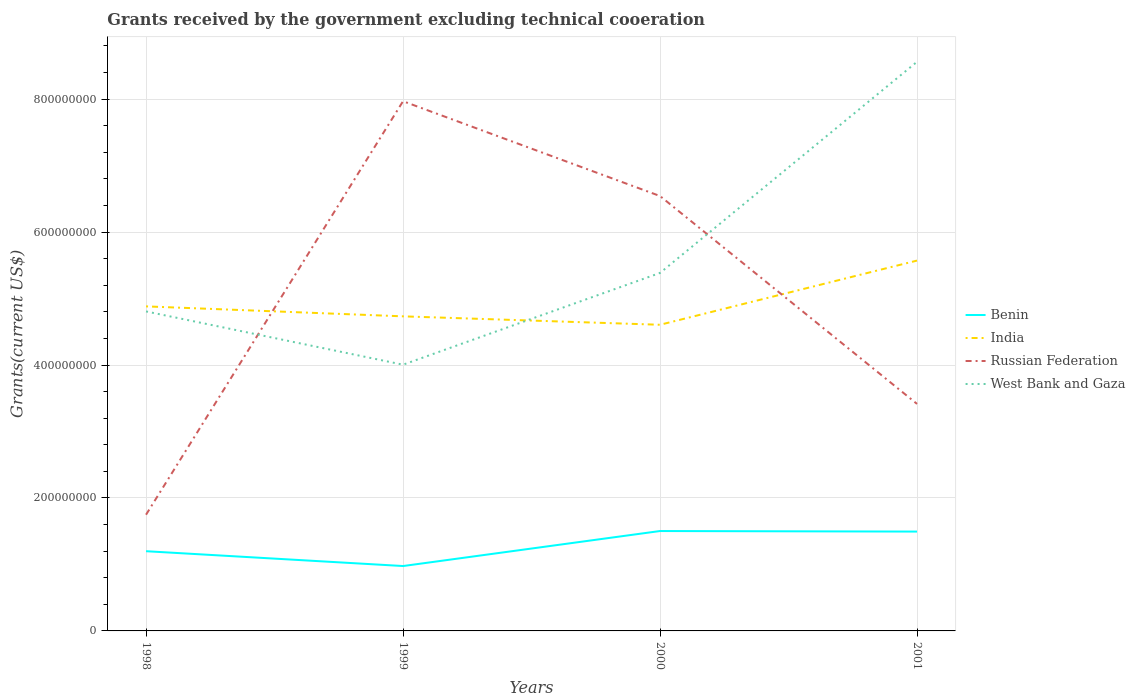How many different coloured lines are there?
Provide a short and direct response. 4. Across all years, what is the maximum total grants received by the government in Benin?
Keep it short and to the point. 9.76e+07. In which year was the total grants received by the government in Russian Federation maximum?
Keep it short and to the point. 1998. What is the total total grants received by the government in India in the graph?
Your answer should be compact. -9.66e+07. What is the difference between the highest and the second highest total grants received by the government in Benin?
Your answer should be compact. 5.27e+07. What is the difference between the highest and the lowest total grants received by the government in India?
Offer a very short reply. 1. How many lines are there?
Make the answer very short. 4. How many years are there in the graph?
Keep it short and to the point. 4. Are the values on the major ticks of Y-axis written in scientific E-notation?
Your response must be concise. No. Does the graph contain any zero values?
Ensure brevity in your answer.  No. How are the legend labels stacked?
Your answer should be compact. Vertical. What is the title of the graph?
Your answer should be very brief. Grants received by the government excluding technical cooeration. What is the label or title of the X-axis?
Ensure brevity in your answer.  Years. What is the label or title of the Y-axis?
Ensure brevity in your answer.  Grants(current US$). What is the Grants(current US$) in Benin in 1998?
Keep it short and to the point. 1.20e+08. What is the Grants(current US$) of India in 1998?
Offer a terse response. 4.88e+08. What is the Grants(current US$) in Russian Federation in 1998?
Give a very brief answer. 1.75e+08. What is the Grants(current US$) of West Bank and Gaza in 1998?
Offer a very short reply. 4.81e+08. What is the Grants(current US$) in Benin in 1999?
Offer a very short reply. 9.76e+07. What is the Grants(current US$) in India in 1999?
Your answer should be very brief. 4.73e+08. What is the Grants(current US$) of Russian Federation in 1999?
Make the answer very short. 7.97e+08. What is the Grants(current US$) in West Bank and Gaza in 1999?
Provide a short and direct response. 4.01e+08. What is the Grants(current US$) of Benin in 2000?
Ensure brevity in your answer.  1.50e+08. What is the Grants(current US$) in India in 2000?
Keep it short and to the point. 4.61e+08. What is the Grants(current US$) in Russian Federation in 2000?
Ensure brevity in your answer.  6.54e+08. What is the Grants(current US$) of West Bank and Gaza in 2000?
Provide a succinct answer. 5.39e+08. What is the Grants(current US$) of Benin in 2001?
Your response must be concise. 1.49e+08. What is the Grants(current US$) of India in 2001?
Provide a succinct answer. 5.57e+08. What is the Grants(current US$) in Russian Federation in 2001?
Ensure brevity in your answer.  3.42e+08. What is the Grants(current US$) of West Bank and Gaza in 2001?
Provide a succinct answer. 8.56e+08. Across all years, what is the maximum Grants(current US$) in Benin?
Offer a very short reply. 1.50e+08. Across all years, what is the maximum Grants(current US$) of India?
Provide a short and direct response. 5.57e+08. Across all years, what is the maximum Grants(current US$) of Russian Federation?
Your answer should be compact. 7.97e+08. Across all years, what is the maximum Grants(current US$) of West Bank and Gaza?
Your answer should be compact. 8.56e+08. Across all years, what is the minimum Grants(current US$) of Benin?
Provide a short and direct response. 9.76e+07. Across all years, what is the minimum Grants(current US$) of India?
Your answer should be compact. 4.61e+08. Across all years, what is the minimum Grants(current US$) of Russian Federation?
Offer a very short reply. 1.75e+08. Across all years, what is the minimum Grants(current US$) in West Bank and Gaza?
Make the answer very short. 4.01e+08. What is the total Grants(current US$) of Benin in the graph?
Make the answer very short. 5.17e+08. What is the total Grants(current US$) of India in the graph?
Offer a very short reply. 1.98e+09. What is the total Grants(current US$) of Russian Federation in the graph?
Provide a succinct answer. 1.97e+09. What is the total Grants(current US$) of West Bank and Gaza in the graph?
Provide a short and direct response. 2.28e+09. What is the difference between the Grants(current US$) in Benin in 1998 and that in 1999?
Your answer should be very brief. 2.23e+07. What is the difference between the Grants(current US$) in India in 1998 and that in 1999?
Offer a terse response. 1.50e+07. What is the difference between the Grants(current US$) in Russian Federation in 1998 and that in 1999?
Your response must be concise. -6.22e+08. What is the difference between the Grants(current US$) of West Bank and Gaza in 1998 and that in 1999?
Your answer should be very brief. 8.02e+07. What is the difference between the Grants(current US$) in Benin in 1998 and that in 2000?
Provide a succinct answer. -3.04e+07. What is the difference between the Grants(current US$) in India in 1998 and that in 2000?
Give a very brief answer. 2.77e+07. What is the difference between the Grants(current US$) of Russian Federation in 1998 and that in 2000?
Keep it short and to the point. -4.79e+08. What is the difference between the Grants(current US$) of West Bank and Gaza in 1998 and that in 2000?
Offer a very short reply. -5.79e+07. What is the difference between the Grants(current US$) of Benin in 1998 and that in 2001?
Make the answer very short. -2.95e+07. What is the difference between the Grants(current US$) of India in 1998 and that in 2001?
Keep it short and to the point. -6.89e+07. What is the difference between the Grants(current US$) in Russian Federation in 1998 and that in 2001?
Ensure brevity in your answer.  -1.67e+08. What is the difference between the Grants(current US$) of West Bank and Gaza in 1998 and that in 2001?
Ensure brevity in your answer.  -3.76e+08. What is the difference between the Grants(current US$) in Benin in 1999 and that in 2000?
Provide a succinct answer. -5.27e+07. What is the difference between the Grants(current US$) in India in 1999 and that in 2000?
Provide a short and direct response. 1.27e+07. What is the difference between the Grants(current US$) in Russian Federation in 1999 and that in 2000?
Your response must be concise. 1.43e+08. What is the difference between the Grants(current US$) in West Bank and Gaza in 1999 and that in 2000?
Keep it short and to the point. -1.38e+08. What is the difference between the Grants(current US$) of Benin in 1999 and that in 2001?
Make the answer very short. -5.18e+07. What is the difference between the Grants(current US$) of India in 1999 and that in 2001?
Give a very brief answer. -8.39e+07. What is the difference between the Grants(current US$) of Russian Federation in 1999 and that in 2001?
Give a very brief answer. 4.55e+08. What is the difference between the Grants(current US$) in West Bank and Gaza in 1999 and that in 2001?
Your answer should be compact. -4.56e+08. What is the difference between the Grants(current US$) of Benin in 2000 and that in 2001?
Keep it short and to the point. 8.30e+05. What is the difference between the Grants(current US$) in India in 2000 and that in 2001?
Your answer should be very brief. -9.66e+07. What is the difference between the Grants(current US$) in Russian Federation in 2000 and that in 2001?
Ensure brevity in your answer.  3.13e+08. What is the difference between the Grants(current US$) in West Bank and Gaza in 2000 and that in 2001?
Offer a very short reply. -3.18e+08. What is the difference between the Grants(current US$) in Benin in 1998 and the Grants(current US$) in India in 1999?
Keep it short and to the point. -3.53e+08. What is the difference between the Grants(current US$) in Benin in 1998 and the Grants(current US$) in Russian Federation in 1999?
Provide a short and direct response. -6.77e+08. What is the difference between the Grants(current US$) of Benin in 1998 and the Grants(current US$) of West Bank and Gaza in 1999?
Provide a succinct answer. -2.81e+08. What is the difference between the Grants(current US$) of India in 1998 and the Grants(current US$) of Russian Federation in 1999?
Offer a very short reply. -3.09e+08. What is the difference between the Grants(current US$) in India in 1998 and the Grants(current US$) in West Bank and Gaza in 1999?
Ensure brevity in your answer.  8.77e+07. What is the difference between the Grants(current US$) of Russian Federation in 1998 and the Grants(current US$) of West Bank and Gaza in 1999?
Offer a very short reply. -2.26e+08. What is the difference between the Grants(current US$) of Benin in 1998 and the Grants(current US$) of India in 2000?
Keep it short and to the point. -3.41e+08. What is the difference between the Grants(current US$) in Benin in 1998 and the Grants(current US$) in Russian Federation in 2000?
Your answer should be compact. -5.34e+08. What is the difference between the Grants(current US$) in Benin in 1998 and the Grants(current US$) in West Bank and Gaza in 2000?
Provide a short and direct response. -4.19e+08. What is the difference between the Grants(current US$) in India in 1998 and the Grants(current US$) in Russian Federation in 2000?
Offer a terse response. -1.66e+08. What is the difference between the Grants(current US$) of India in 1998 and the Grants(current US$) of West Bank and Gaza in 2000?
Keep it short and to the point. -5.03e+07. What is the difference between the Grants(current US$) of Russian Federation in 1998 and the Grants(current US$) of West Bank and Gaza in 2000?
Make the answer very short. -3.64e+08. What is the difference between the Grants(current US$) in Benin in 1998 and the Grants(current US$) in India in 2001?
Offer a very short reply. -4.37e+08. What is the difference between the Grants(current US$) in Benin in 1998 and the Grants(current US$) in Russian Federation in 2001?
Offer a terse response. -2.22e+08. What is the difference between the Grants(current US$) in Benin in 1998 and the Grants(current US$) in West Bank and Gaza in 2001?
Provide a succinct answer. -7.36e+08. What is the difference between the Grants(current US$) of India in 1998 and the Grants(current US$) of Russian Federation in 2001?
Provide a succinct answer. 1.47e+08. What is the difference between the Grants(current US$) in India in 1998 and the Grants(current US$) in West Bank and Gaza in 2001?
Provide a succinct answer. -3.68e+08. What is the difference between the Grants(current US$) of Russian Federation in 1998 and the Grants(current US$) of West Bank and Gaza in 2001?
Offer a very short reply. -6.81e+08. What is the difference between the Grants(current US$) in Benin in 1999 and the Grants(current US$) in India in 2000?
Your answer should be compact. -3.63e+08. What is the difference between the Grants(current US$) in Benin in 1999 and the Grants(current US$) in Russian Federation in 2000?
Offer a very short reply. -5.57e+08. What is the difference between the Grants(current US$) in Benin in 1999 and the Grants(current US$) in West Bank and Gaza in 2000?
Ensure brevity in your answer.  -4.41e+08. What is the difference between the Grants(current US$) of India in 1999 and the Grants(current US$) of Russian Federation in 2000?
Provide a succinct answer. -1.81e+08. What is the difference between the Grants(current US$) in India in 1999 and the Grants(current US$) in West Bank and Gaza in 2000?
Ensure brevity in your answer.  -6.53e+07. What is the difference between the Grants(current US$) in Russian Federation in 1999 and the Grants(current US$) in West Bank and Gaza in 2000?
Ensure brevity in your answer.  2.58e+08. What is the difference between the Grants(current US$) in Benin in 1999 and the Grants(current US$) in India in 2001?
Offer a very short reply. -4.60e+08. What is the difference between the Grants(current US$) of Benin in 1999 and the Grants(current US$) of Russian Federation in 2001?
Keep it short and to the point. -2.44e+08. What is the difference between the Grants(current US$) of Benin in 1999 and the Grants(current US$) of West Bank and Gaza in 2001?
Provide a succinct answer. -7.59e+08. What is the difference between the Grants(current US$) in India in 1999 and the Grants(current US$) in Russian Federation in 2001?
Ensure brevity in your answer.  1.32e+08. What is the difference between the Grants(current US$) of India in 1999 and the Grants(current US$) of West Bank and Gaza in 2001?
Make the answer very short. -3.83e+08. What is the difference between the Grants(current US$) in Russian Federation in 1999 and the Grants(current US$) in West Bank and Gaza in 2001?
Give a very brief answer. -5.93e+07. What is the difference between the Grants(current US$) in Benin in 2000 and the Grants(current US$) in India in 2001?
Provide a short and direct response. -4.07e+08. What is the difference between the Grants(current US$) of Benin in 2000 and the Grants(current US$) of Russian Federation in 2001?
Provide a succinct answer. -1.91e+08. What is the difference between the Grants(current US$) of Benin in 2000 and the Grants(current US$) of West Bank and Gaza in 2001?
Keep it short and to the point. -7.06e+08. What is the difference between the Grants(current US$) of India in 2000 and the Grants(current US$) of Russian Federation in 2001?
Provide a succinct answer. 1.19e+08. What is the difference between the Grants(current US$) in India in 2000 and the Grants(current US$) in West Bank and Gaza in 2001?
Your response must be concise. -3.96e+08. What is the difference between the Grants(current US$) in Russian Federation in 2000 and the Grants(current US$) in West Bank and Gaza in 2001?
Ensure brevity in your answer.  -2.02e+08. What is the average Grants(current US$) in Benin per year?
Give a very brief answer. 1.29e+08. What is the average Grants(current US$) in India per year?
Provide a succinct answer. 4.95e+08. What is the average Grants(current US$) of Russian Federation per year?
Ensure brevity in your answer.  4.92e+08. What is the average Grants(current US$) of West Bank and Gaza per year?
Keep it short and to the point. 5.69e+08. In the year 1998, what is the difference between the Grants(current US$) of Benin and Grants(current US$) of India?
Provide a succinct answer. -3.68e+08. In the year 1998, what is the difference between the Grants(current US$) in Benin and Grants(current US$) in Russian Federation?
Offer a terse response. -5.49e+07. In the year 1998, what is the difference between the Grants(current US$) in Benin and Grants(current US$) in West Bank and Gaza?
Keep it short and to the point. -3.61e+08. In the year 1998, what is the difference between the Grants(current US$) of India and Grants(current US$) of Russian Federation?
Your answer should be very brief. 3.13e+08. In the year 1998, what is the difference between the Grants(current US$) in India and Grants(current US$) in West Bank and Gaza?
Ensure brevity in your answer.  7.58e+06. In the year 1998, what is the difference between the Grants(current US$) of Russian Federation and Grants(current US$) of West Bank and Gaza?
Offer a very short reply. -3.06e+08. In the year 1999, what is the difference between the Grants(current US$) in Benin and Grants(current US$) in India?
Your answer should be compact. -3.76e+08. In the year 1999, what is the difference between the Grants(current US$) in Benin and Grants(current US$) in Russian Federation?
Your response must be concise. -6.99e+08. In the year 1999, what is the difference between the Grants(current US$) in Benin and Grants(current US$) in West Bank and Gaza?
Provide a succinct answer. -3.03e+08. In the year 1999, what is the difference between the Grants(current US$) of India and Grants(current US$) of Russian Federation?
Provide a short and direct response. -3.24e+08. In the year 1999, what is the difference between the Grants(current US$) of India and Grants(current US$) of West Bank and Gaza?
Offer a very short reply. 7.27e+07. In the year 1999, what is the difference between the Grants(current US$) in Russian Federation and Grants(current US$) in West Bank and Gaza?
Offer a terse response. 3.96e+08. In the year 2000, what is the difference between the Grants(current US$) of Benin and Grants(current US$) of India?
Offer a very short reply. -3.10e+08. In the year 2000, what is the difference between the Grants(current US$) in Benin and Grants(current US$) in Russian Federation?
Offer a very short reply. -5.04e+08. In the year 2000, what is the difference between the Grants(current US$) of Benin and Grants(current US$) of West Bank and Gaza?
Keep it short and to the point. -3.88e+08. In the year 2000, what is the difference between the Grants(current US$) of India and Grants(current US$) of Russian Federation?
Ensure brevity in your answer.  -1.94e+08. In the year 2000, what is the difference between the Grants(current US$) in India and Grants(current US$) in West Bank and Gaza?
Make the answer very short. -7.80e+07. In the year 2000, what is the difference between the Grants(current US$) of Russian Federation and Grants(current US$) of West Bank and Gaza?
Make the answer very short. 1.16e+08. In the year 2001, what is the difference between the Grants(current US$) in Benin and Grants(current US$) in India?
Your response must be concise. -4.08e+08. In the year 2001, what is the difference between the Grants(current US$) in Benin and Grants(current US$) in Russian Federation?
Keep it short and to the point. -1.92e+08. In the year 2001, what is the difference between the Grants(current US$) of Benin and Grants(current US$) of West Bank and Gaza?
Make the answer very short. -7.07e+08. In the year 2001, what is the difference between the Grants(current US$) of India and Grants(current US$) of Russian Federation?
Ensure brevity in your answer.  2.16e+08. In the year 2001, what is the difference between the Grants(current US$) of India and Grants(current US$) of West Bank and Gaza?
Give a very brief answer. -2.99e+08. In the year 2001, what is the difference between the Grants(current US$) in Russian Federation and Grants(current US$) in West Bank and Gaza?
Your answer should be compact. -5.15e+08. What is the ratio of the Grants(current US$) in Benin in 1998 to that in 1999?
Offer a terse response. 1.23. What is the ratio of the Grants(current US$) in India in 1998 to that in 1999?
Provide a short and direct response. 1.03. What is the ratio of the Grants(current US$) in Russian Federation in 1998 to that in 1999?
Your response must be concise. 0.22. What is the ratio of the Grants(current US$) in West Bank and Gaza in 1998 to that in 1999?
Ensure brevity in your answer.  1.2. What is the ratio of the Grants(current US$) in Benin in 1998 to that in 2000?
Give a very brief answer. 0.8. What is the ratio of the Grants(current US$) in India in 1998 to that in 2000?
Make the answer very short. 1.06. What is the ratio of the Grants(current US$) in Russian Federation in 1998 to that in 2000?
Your answer should be very brief. 0.27. What is the ratio of the Grants(current US$) of West Bank and Gaza in 1998 to that in 2000?
Your response must be concise. 0.89. What is the ratio of the Grants(current US$) in Benin in 1998 to that in 2001?
Make the answer very short. 0.8. What is the ratio of the Grants(current US$) of India in 1998 to that in 2001?
Your answer should be very brief. 0.88. What is the ratio of the Grants(current US$) in Russian Federation in 1998 to that in 2001?
Offer a very short reply. 0.51. What is the ratio of the Grants(current US$) of West Bank and Gaza in 1998 to that in 2001?
Make the answer very short. 0.56. What is the ratio of the Grants(current US$) in Benin in 1999 to that in 2000?
Give a very brief answer. 0.65. What is the ratio of the Grants(current US$) of India in 1999 to that in 2000?
Keep it short and to the point. 1.03. What is the ratio of the Grants(current US$) in Russian Federation in 1999 to that in 2000?
Provide a succinct answer. 1.22. What is the ratio of the Grants(current US$) of West Bank and Gaza in 1999 to that in 2000?
Ensure brevity in your answer.  0.74. What is the ratio of the Grants(current US$) of Benin in 1999 to that in 2001?
Your answer should be very brief. 0.65. What is the ratio of the Grants(current US$) of India in 1999 to that in 2001?
Make the answer very short. 0.85. What is the ratio of the Grants(current US$) in Russian Federation in 1999 to that in 2001?
Offer a terse response. 2.33. What is the ratio of the Grants(current US$) of West Bank and Gaza in 1999 to that in 2001?
Provide a short and direct response. 0.47. What is the ratio of the Grants(current US$) in Benin in 2000 to that in 2001?
Your response must be concise. 1.01. What is the ratio of the Grants(current US$) in India in 2000 to that in 2001?
Provide a succinct answer. 0.83. What is the ratio of the Grants(current US$) in Russian Federation in 2000 to that in 2001?
Your answer should be compact. 1.92. What is the ratio of the Grants(current US$) in West Bank and Gaza in 2000 to that in 2001?
Offer a very short reply. 0.63. What is the difference between the highest and the second highest Grants(current US$) of Benin?
Your answer should be compact. 8.30e+05. What is the difference between the highest and the second highest Grants(current US$) of India?
Ensure brevity in your answer.  6.89e+07. What is the difference between the highest and the second highest Grants(current US$) of Russian Federation?
Keep it short and to the point. 1.43e+08. What is the difference between the highest and the second highest Grants(current US$) in West Bank and Gaza?
Ensure brevity in your answer.  3.18e+08. What is the difference between the highest and the lowest Grants(current US$) of Benin?
Give a very brief answer. 5.27e+07. What is the difference between the highest and the lowest Grants(current US$) of India?
Your response must be concise. 9.66e+07. What is the difference between the highest and the lowest Grants(current US$) in Russian Federation?
Offer a very short reply. 6.22e+08. What is the difference between the highest and the lowest Grants(current US$) in West Bank and Gaza?
Make the answer very short. 4.56e+08. 